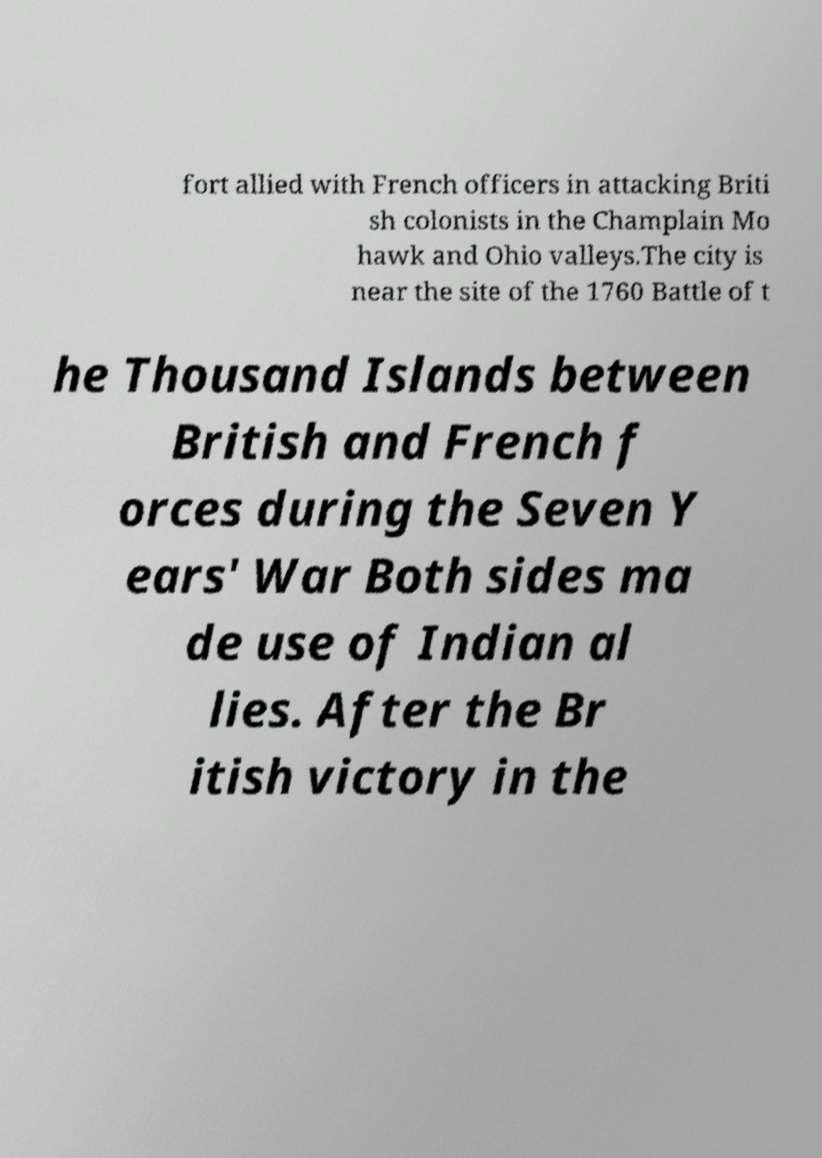Could you assist in decoding the text presented in this image and type it out clearly? fort allied with French officers in attacking Briti sh colonists in the Champlain Mo hawk and Ohio valleys.The city is near the site of the 1760 Battle of t he Thousand Islands between British and French f orces during the Seven Y ears' War Both sides ma de use of Indian al lies. After the Br itish victory in the 